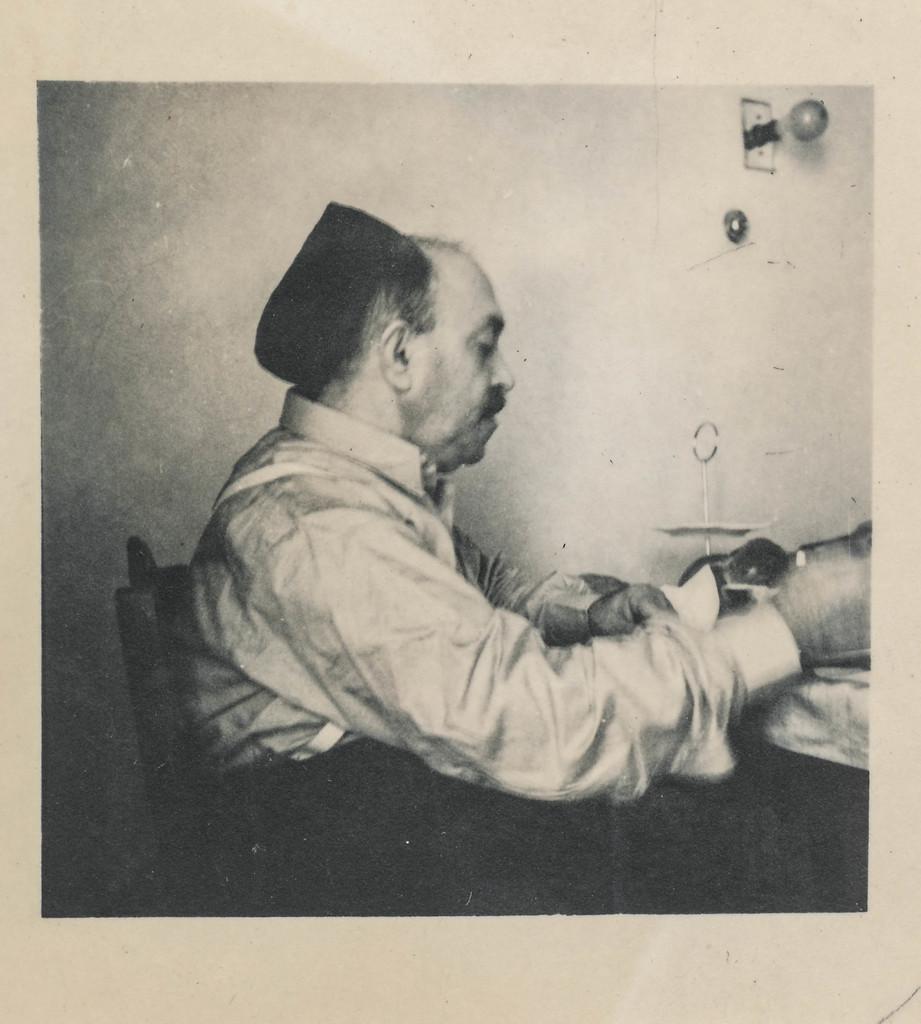In one or two sentences, can you explain what this image depicts? In this image, we can see black and white poster with a person sitting on a chair. We can also see the wall with objects on it. 